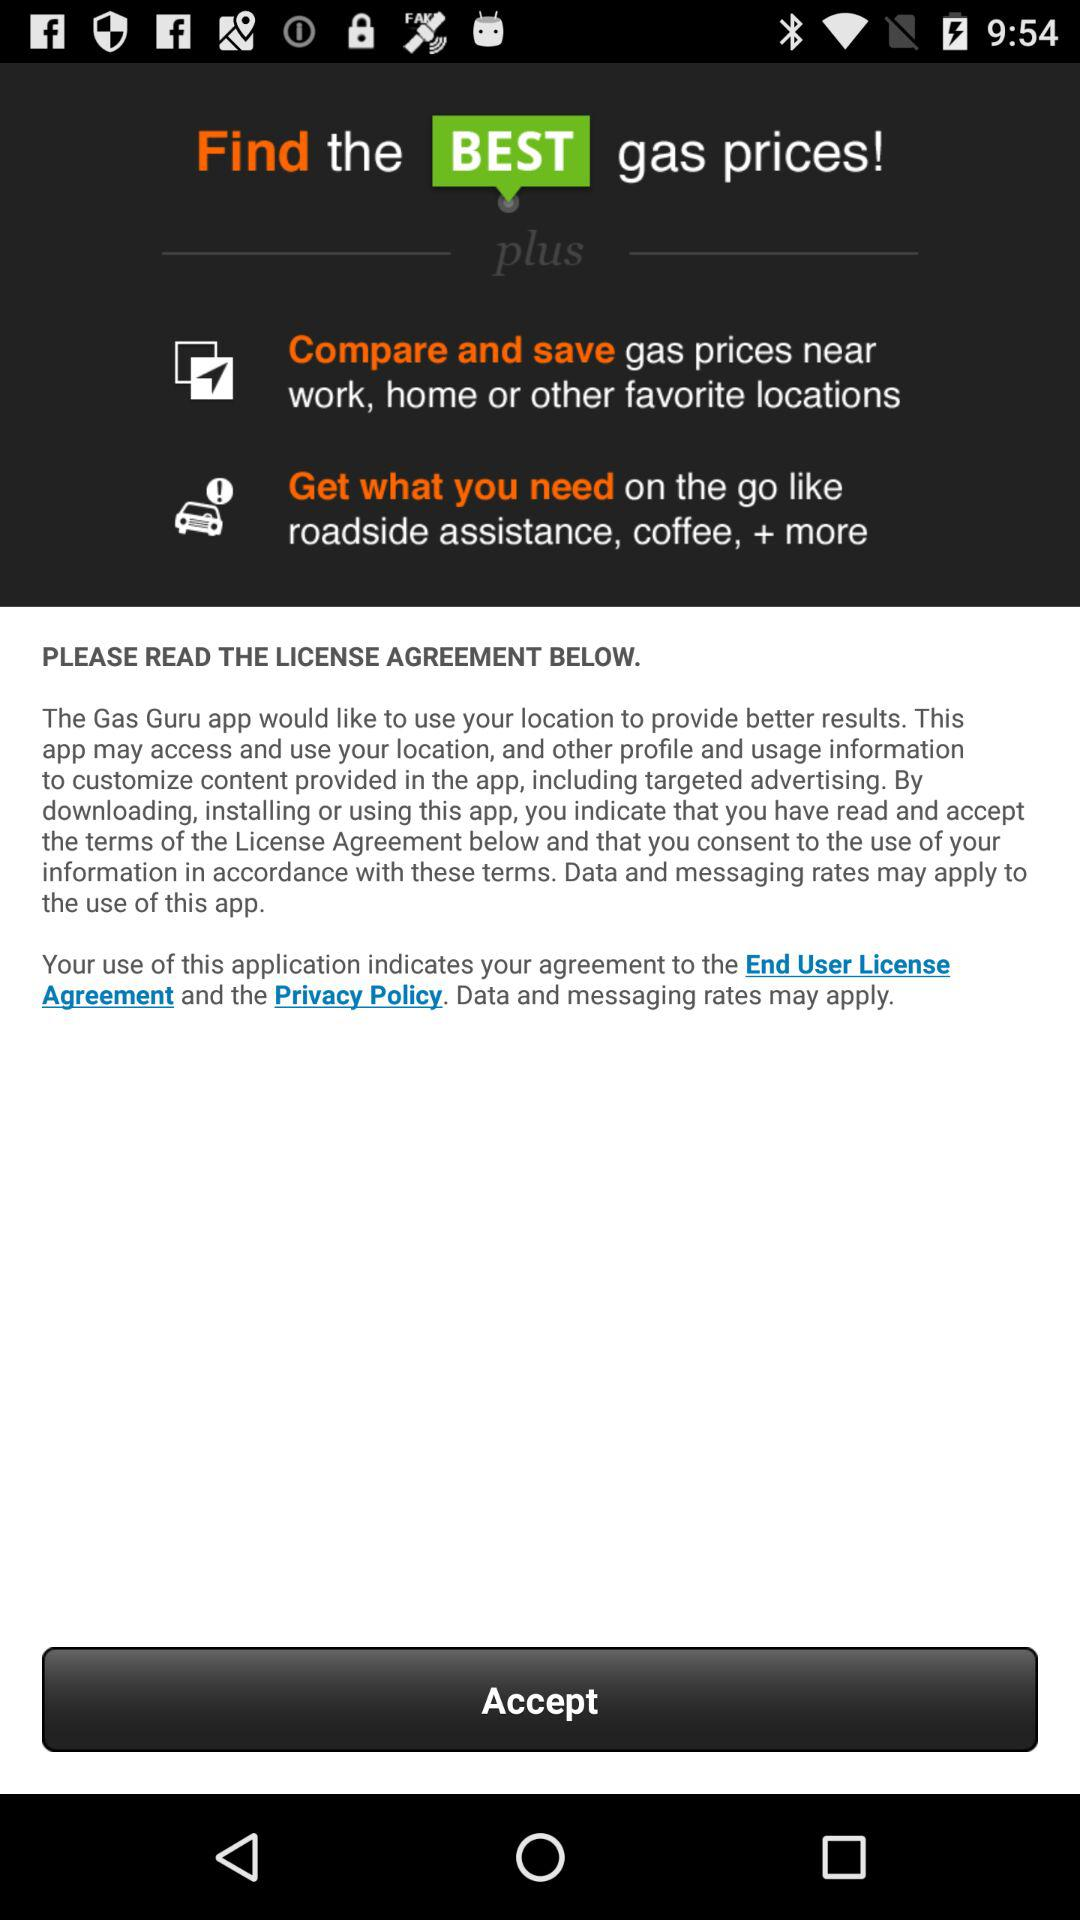What is the end user license agreement?
When the provided information is insufficient, respond with <no answer>. <no answer> 